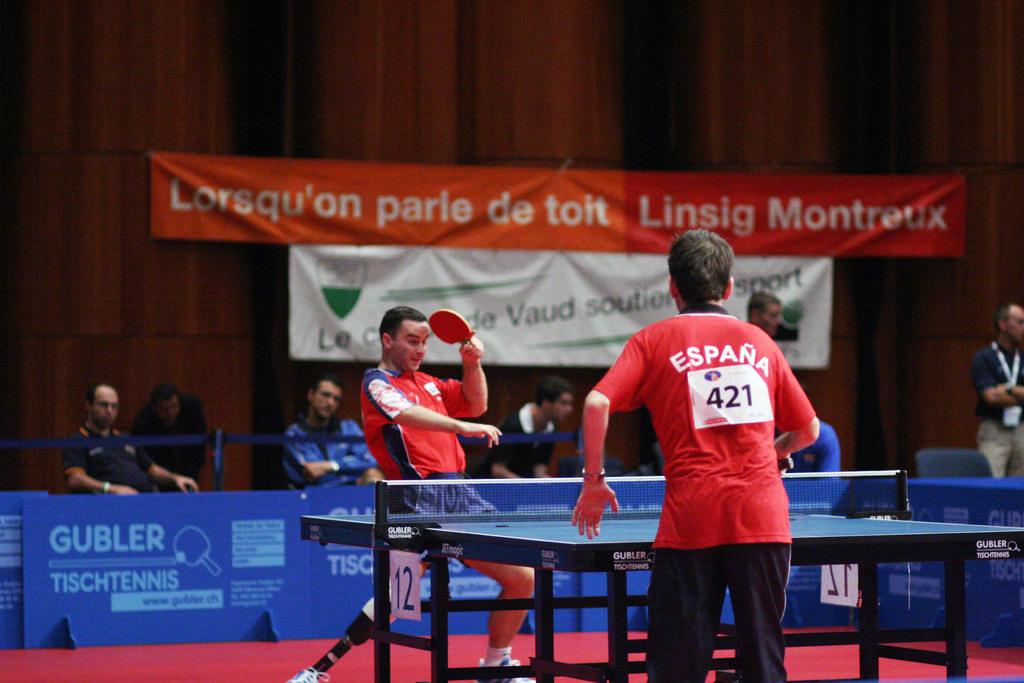What is the number of the player?
Provide a short and direct response. 421. What is the players number?
Keep it short and to the point. 421. 